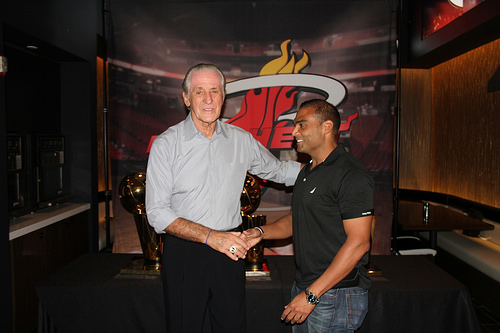<image>
Is there a man on the old man? No. The man is not positioned on the old man. They may be near each other, but the man is not supported by or resting on top of the old man. Is there a black man to the left of the white man? No. The black man is not to the left of the white man. From this viewpoint, they have a different horizontal relationship. 